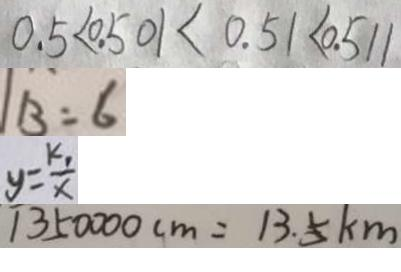<formula> <loc_0><loc_0><loc_500><loc_500>0 . 5 < 0 . 5 0 1 < 0 . 5 1 < 0 . 5 1 1 
 B = 6 
 y = \frac { k _ { 1 } } { x } 
 1 3 5 0 0 0 0 c m = 1 3 . 5 k m</formula> 